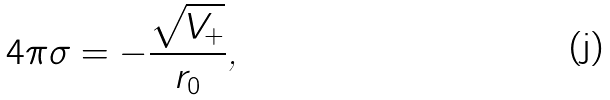Convert formula to latex. <formula><loc_0><loc_0><loc_500><loc_500>4 \pi \sigma = - \frac { \sqrt { V _ { + } } } { r _ { 0 } } \text {,}</formula> 